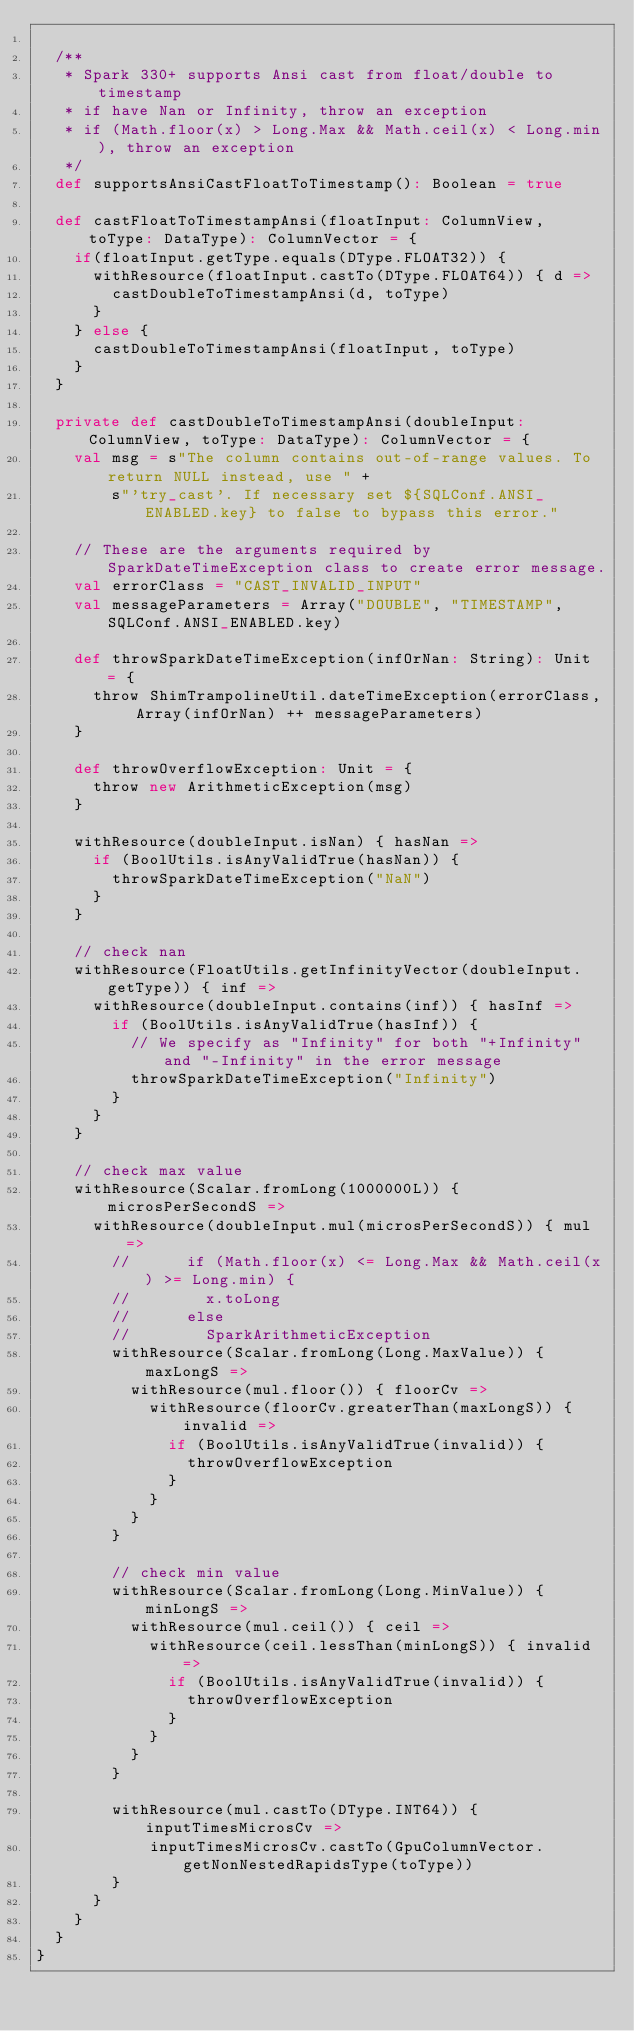<code> <loc_0><loc_0><loc_500><loc_500><_Scala_>
  /**
   * Spark 330+ supports Ansi cast from float/double to timestamp
   * if have Nan or Infinity, throw an exception
   * if (Math.floor(x) > Long.Max && Math.ceil(x) < Long.min), throw an exception
   */
  def supportsAnsiCastFloatToTimestamp(): Boolean = true

  def castFloatToTimestampAnsi(floatInput: ColumnView, toType: DataType): ColumnVector = {
    if(floatInput.getType.equals(DType.FLOAT32)) {
      withResource(floatInput.castTo(DType.FLOAT64)) { d =>
        castDoubleToTimestampAnsi(d, toType)
      }
    } else {
      castDoubleToTimestampAnsi(floatInput, toType)
    }
  }

  private def castDoubleToTimestampAnsi(doubleInput: ColumnView, toType: DataType): ColumnVector = {
    val msg = s"The column contains out-of-range values. To return NULL instead, use " +
        s"'try_cast'. If necessary set ${SQLConf.ANSI_ENABLED.key} to false to bypass this error."

    // These are the arguments required by SparkDateTimeException class to create error message.
    val errorClass = "CAST_INVALID_INPUT"
    val messageParameters = Array("DOUBLE", "TIMESTAMP", SQLConf.ANSI_ENABLED.key)

    def throwSparkDateTimeException(infOrNan: String): Unit = {
      throw ShimTrampolineUtil.dateTimeException(errorClass, Array(infOrNan) ++ messageParameters)
    }

    def throwOverflowException: Unit = {
      throw new ArithmeticException(msg)
    }

    withResource(doubleInput.isNan) { hasNan =>
      if (BoolUtils.isAnyValidTrue(hasNan)) {
        throwSparkDateTimeException("NaN")
      }
    }

    // check nan
    withResource(FloatUtils.getInfinityVector(doubleInput.getType)) { inf =>
      withResource(doubleInput.contains(inf)) { hasInf =>
        if (BoolUtils.isAnyValidTrue(hasInf)) {
          // We specify as "Infinity" for both "+Infinity" and "-Infinity" in the error message
          throwSparkDateTimeException("Infinity")
        }
      }
    }

    // check max value
    withResource(Scalar.fromLong(1000000L)) { microsPerSecondS =>
      withResource(doubleInput.mul(microsPerSecondS)) { mul =>
        //      if (Math.floor(x) <= Long.Max && Math.ceil(x) >= Long.min) {
        //        x.toLong
        //      else
        //        SparkArithmeticException
        withResource(Scalar.fromLong(Long.MaxValue)) { maxLongS =>
          withResource(mul.floor()) { floorCv =>
            withResource(floorCv.greaterThan(maxLongS)) { invalid =>
              if (BoolUtils.isAnyValidTrue(invalid)) {
                throwOverflowException
              }
            }
          }
        }

        // check min value
        withResource(Scalar.fromLong(Long.MinValue)) { minLongS =>
          withResource(mul.ceil()) { ceil =>
            withResource(ceil.lessThan(minLongS)) { invalid =>
              if (BoolUtils.isAnyValidTrue(invalid)) {
                throwOverflowException
              }
            }
          }
        }

        withResource(mul.castTo(DType.INT64)) { inputTimesMicrosCv =>
            inputTimesMicrosCv.castTo(GpuColumnVector.getNonNestedRapidsType(toType))
        }
      }
    }
  }
}
</code> 